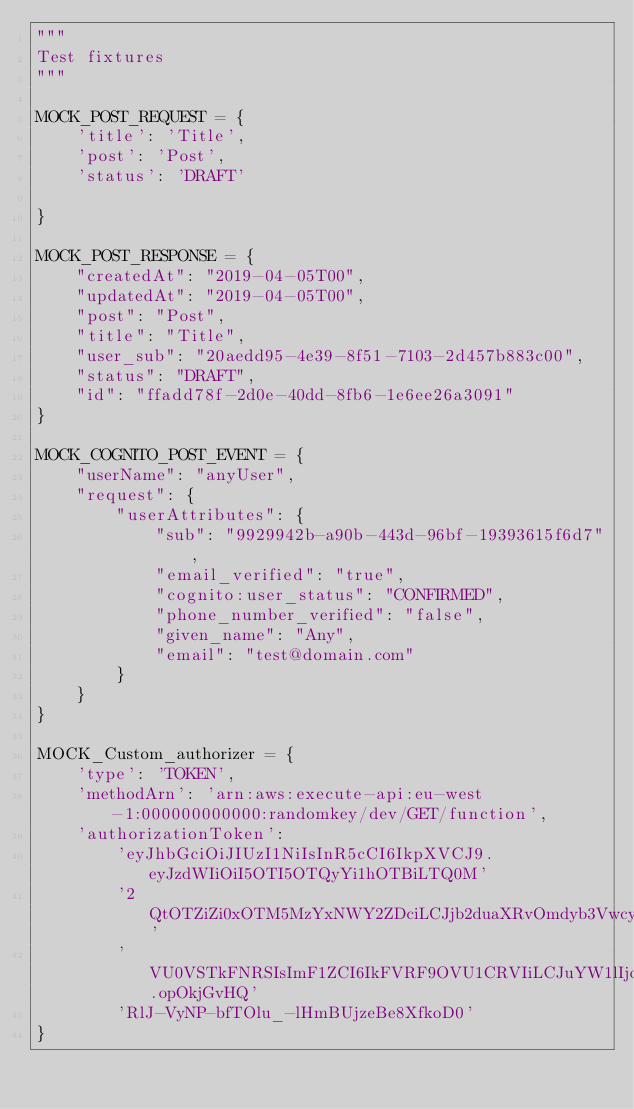<code> <loc_0><loc_0><loc_500><loc_500><_Python_>"""
Test fixtures
"""

MOCK_POST_REQUEST = {
    'title': 'Title',
    'post': 'Post',
    'status': 'DRAFT'

}

MOCK_POST_RESPONSE = {
    "createdAt": "2019-04-05T00",
    "updatedAt": "2019-04-05T00",
    "post": "Post",
    "title": "Title",
    "user_sub": "20aedd95-4e39-8f51-7103-2d457b883c00",
    "status": "DRAFT",
    "id": "ffadd78f-2d0e-40dd-8fb6-1e6ee26a3091"
}

MOCK_COGNITO_POST_EVENT = {
    "userName": "anyUser",
    "request": {
        "userAttributes": {
            "sub": "9929942b-a90b-443d-96bf-19393615f6d7",
            "email_verified": "true",
            "cognito:user_status": "CONFIRMED",
            "phone_number_verified": "false",
            "given_name": "Any",
            "email": "test@domain.com"
        }
    }
}

MOCK_Custom_authorizer = {
    'type': 'TOKEN',
    'methodArn': 'arn:aws:execute-api:eu-west-1:000000000000:randomkey/dev/GET/function',
    'authorizationToken':
        'eyJhbGciOiJIUzI1NiIsInR5cCI6IkpXVCJ9.eyJzdWIiOiI5OTI5OTQyYi1hOTBiLTQ0M'
        '2QtOTZiZi0xOTM5MzYxNWY2ZDciLCJjb2duaXRvOmdyb3VwcyI6W10sImNvZ25pdG86dXNlcm5hbWUiOiJ'
        'VU0VSTkFNRSIsImF1ZCI6IkFVRF9OVU1CRVIiLCJuYW1lIjoiVXNlciJ9.opOkjGvHQ'
        'RlJ-VyNP-bfTOlu_-lHmBUjzeBe8XfkoD0'
}
</code> 